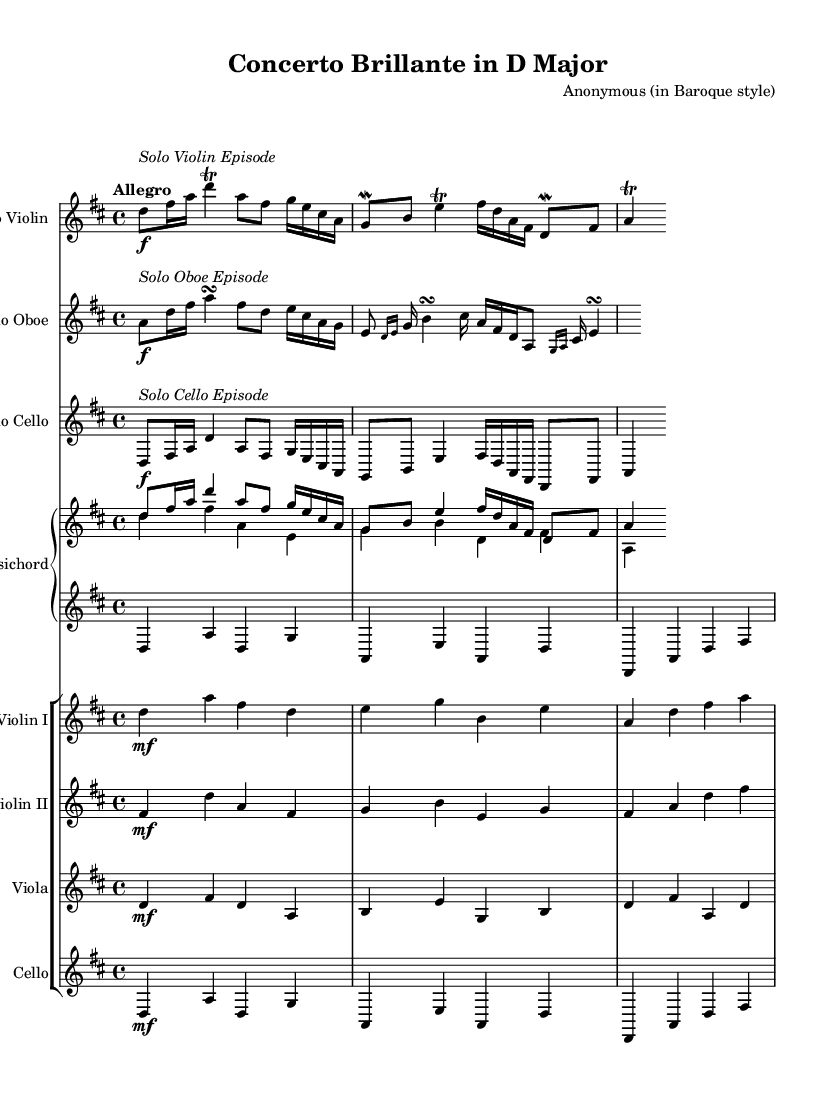What is the key signature of this music? The key signature is indicated by the sharps or flats at the beginning of the staff. In this case, there are two sharps (F# and C#), which correspond to the D major key.
Answer: D major What is the time signature of this piece? The time signature is shown at the beginning of the staff and indicates how many beats are in each measure. Here, it is displayed as 4/4, meaning there are four beats in a measure.
Answer: 4/4 What is the tempo marking for this piece? The tempo marking appears above the staff and usually indicates the speed of the music. In this sheet music, it is marked "Allegro," which signifies a fast tempo.
Answer: Allegro How many solo instrumentalists are featured in this section? The sheet music lists three distinct solo parts: Solo Violin, Solo Oboe, and Solo Cello. Thus, there are three solo instrumentalists.
Answer: Three Which instrument is notated with the markup "Solo Violin Episode"? The markup for "Solo Violin Episode" specifically labels the part for the violin, indicating that this section focuses on the solo violin's performance.
Answer: Solo Violin What type of ensemble is depicted in this sheet music? The arrangement includes solo instruments accompanied by a keyboard and string ensemble, characteristic of Baroque music which often features concertos with soloists and orchestra.
Answer: Baroque ensemble What is the significance of the trill indicated in the solo parts? Trills are ornamental techniques common in Baroque music, indicated by a "tr" or symbol, signifying a rapid alternation between the written note and the note above it, adding expressiveness to the performance.
Answer: Ornamentation 